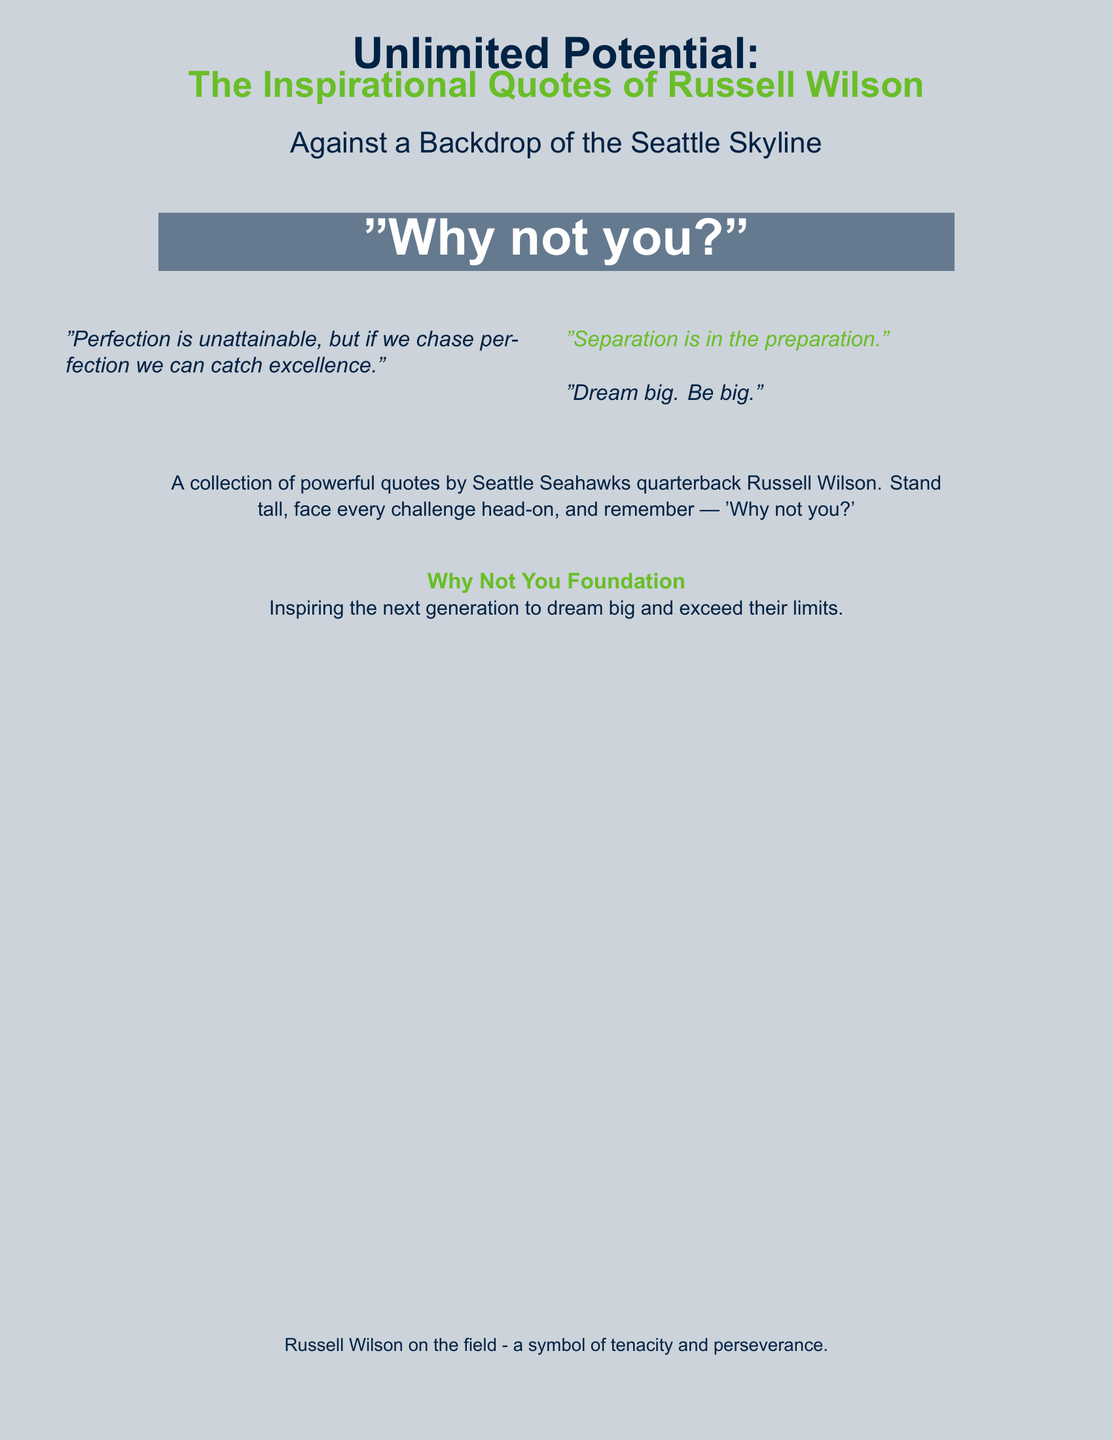What is the title of the book? The title is prominently displayed on the cover in large font.
Answer: Unlimited Potential: The Inspirational Quotes of Russell Wilson Who is the author of the book? The book features powerful quotes by a well-known NFL quarterback, which indicates the author is him.
Answer: Russell Wilson What is the inspirational phrase featured on the cover? The phrase is highlighted in a unique box on the cover to emphasize its importance.
Answer: "Why not you?" What color is the backdrop of the cover? The color is specified in the document and is associated with the Seattle Seahawks theme.
Answer: Seahawks blue What is one of the quotes included in the document? The document presents quotes from Russell Wilson, which contribute to the theme of inspiration and motivation.
Answer: "Dream big. Be big." What is the primary theme of the Why Not You Foundation mentioned? The document explains the foundation's objective, focusing on empowering the next generation.
Answer: Dream big and exceed their limits How many columns are used for the quotes? The layout is designed to present quotes side-by-side for visual impact.
Answer: Two What is the overall mood conveyed by the book cover? The design and quotes aim to inspire and motivate individuals, especially the younger audience.
Answer: Inspirational 